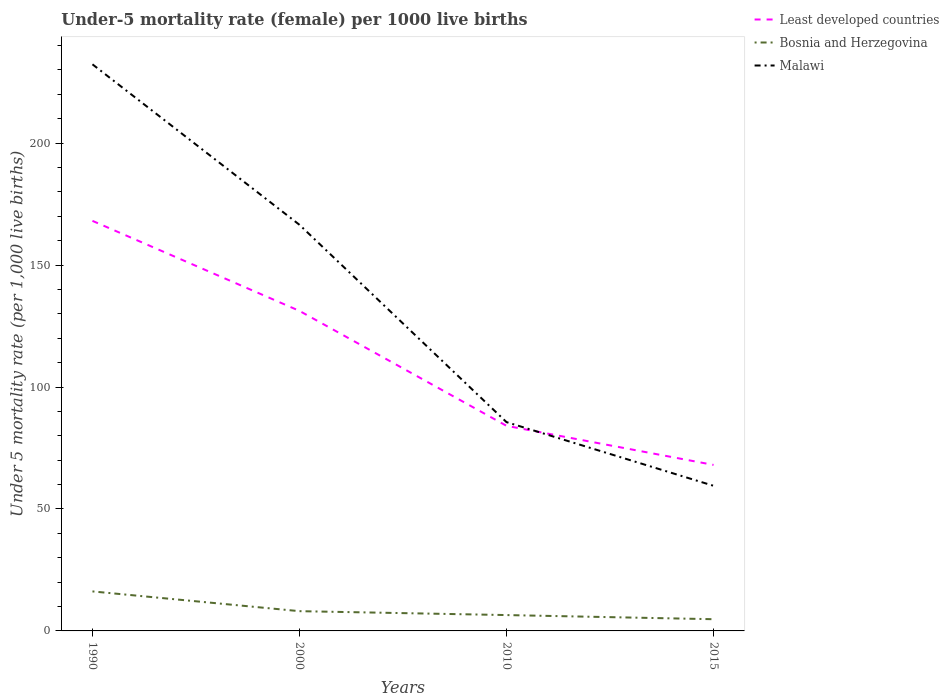Does the line corresponding to Least developed countries intersect with the line corresponding to Malawi?
Offer a very short reply. Yes. Is the number of lines equal to the number of legend labels?
Give a very brief answer. Yes. Across all years, what is the maximum under-five mortality rate in Malawi?
Provide a succinct answer. 59.5. In which year was the under-five mortality rate in Malawi maximum?
Ensure brevity in your answer.  2015. What is the total under-five mortality rate in Least developed countries in the graph?
Provide a succinct answer. 100.06. What is the difference between the highest and the second highest under-five mortality rate in Least developed countries?
Your answer should be very brief. 100.06. Is the under-five mortality rate in Malawi strictly greater than the under-five mortality rate in Least developed countries over the years?
Your response must be concise. No. How many lines are there?
Your response must be concise. 3. How many legend labels are there?
Ensure brevity in your answer.  3. How are the legend labels stacked?
Your answer should be very brief. Vertical. What is the title of the graph?
Make the answer very short. Under-5 mortality rate (female) per 1000 live births. What is the label or title of the Y-axis?
Your answer should be very brief. Under 5 mortality rate (per 1,0 live births). What is the Under 5 mortality rate (per 1,000 live births) in Least developed countries in 1990?
Provide a short and direct response. 168.12. What is the Under 5 mortality rate (per 1,000 live births) of Bosnia and Herzegovina in 1990?
Your answer should be compact. 16.2. What is the Under 5 mortality rate (per 1,000 live births) in Malawi in 1990?
Make the answer very short. 232.3. What is the Under 5 mortality rate (per 1,000 live births) in Least developed countries in 2000?
Your answer should be very brief. 131.2. What is the Under 5 mortality rate (per 1,000 live births) of Bosnia and Herzegovina in 2000?
Provide a short and direct response. 8.1. What is the Under 5 mortality rate (per 1,000 live births) in Malawi in 2000?
Provide a succinct answer. 166.5. What is the Under 5 mortality rate (per 1,000 live births) in Least developed countries in 2010?
Your answer should be very brief. 84.09. What is the Under 5 mortality rate (per 1,000 live births) in Bosnia and Herzegovina in 2010?
Your answer should be compact. 6.5. What is the Under 5 mortality rate (per 1,000 live births) of Malawi in 2010?
Provide a succinct answer. 85.6. What is the Under 5 mortality rate (per 1,000 live births) in Least developed countries in 2015?
Provide a short and direct response. 68.06. What is the Under 5 mortality rate (per 1,000 live births) in Malawi in 2015?
Your answer should be very brief. 59.5. Across all years, what is the maximum Under 5 mortality rate (per 1,000 live births) of Least developed countries?
Provide a succinct answer. 168.12. Across all years, what is the maximum Under 5 mortality rate (per 1,000 live births) in Malawi?
Your response must be concise. 232.3. Across all years, what is the minimum Under 5 mortality rate (per 1,000 live births) in Least developed countries?
Your answer should be compact. 68.06. Across all years, what is the minimum Under 5 mortality rate (per 1,000 live births) in Malawi?
Provide a succinct answer. 59.5. What is the total Under 5 mortality rate (per 1,000 live births) in Least developed countries in the graph?
Ensure brevity in your answer.  451.47. What is the total Under 5 mortality rate (per 1,000 live births) in Bosnia and Herzegovina in the graph?
Provide a short and direct response. 35.6. What is the total Under 5 mortality rate (per 1,000 live births) in Malawi in the graph?
Offer a very short reply. 543.9. What is the difference between the Under 5 mortality rate (per 1,000 live births) in Least developed countries in 1990 and that in 2000?
Give a very brief answer. 36.92. What is the difference between the Under 5 mortality rate (per 1,000 live births) of Malawi in 1990 and that in 2000?
Offer a terse response. 65.8. What is the difference between the Under 5 mortality rate (per 1,000 live births) in Least developed countries in 1990 and that in 2010?
Provide a succinct answer. 84.04. What is the difference between the Under 5 mortality rate (per 1,000 live births) of Bosnia and Herzegovina in 1990 and that in 2010?
Ensure brevity in your answer.  9.7. What is the difference between the Under 5 mortality rate (per 1,000 live births) of Malawi in 1990 and that in 2010?
Your answer should be compact. 146.7. What is the difference between the Under 5 mortality rate (per 1,000 live births) of Least developed countries in 1990 and that in 2015?
Your answer should be very brief. 100.06. What is the difference between the Under 5 mortality rate (per 1,000 live births) in Malawi in 1990 and that in 2015?
Offer a terse response. 172.8. What is the difference between the Under 5 mortality rate (per 1,000 live births) of Least developed countries in 2000 and that in 2010?
Give a very brief answer. 47.12. What is the difference between the Under 5 mortality rate (per 1,000 live births) of Bosnia and Herzegovina in 2000 and that in 2010?
Your answer should be very brief. 1.6. What is the difference between the Under 5 mortality rate (per 1,000 live births) of Malawi in 2000 and that in 2010?
Your answer should be very brief. 80.9. What is the difference between the Under 5 mortality rate (per 1,000 live births) in Least developed countries in 2000 and that in 2015?
Make the answer very short. 63.14. What is the difference between the Under 5 mortality rate (per 1,000 live births) in Bosnia and Herzegovina in 2000 and that in 2015?
Provide a succinct answer. 3.3. What is the difference between the Under 5 mortality rate (per 1,000 live births) of Malawi in 2000 and that in 2015?
Provide a short and direct response. 107. What is the difference between the Under 5 mortality rate (per 1,000 live births) of Least developed countries in 2010 and that in 2015?
Your answer should be very brief. 16.03. What is the difference between the Under 5 mortality rate (per 1,000 live births) of Bosnia and Herzegovina in 2010 and that in 2015?
Provide a succinct answer. 1.7. What is the difference between the Under 5 mortality rate (per 1,000 live births) in Malawi in 2010 and that in 2015?
Make the answer very short. 26.1. What is the difference between the Under 5 mortality rate (per 1,000 live births) in Least developed countries in 1990 and the Under 5 mortality rate (per 1,000 live births) in Bosnia and Herzegovina in 2000?
Provide a short and direct response. 160.02. What is the difference between the Under 5 mortality rate (per 1,000 live births) of Least developed countries in 1990 and the Under 5 mortality rate (per 1,000 live births) of Malawi in 2000?
Your response must be concise. 1.62. What is the difference between the Under 5 mortality rate (per 1,000 live births) in Bosnia and Herzegovina in 1990 and the Under 5 mortality rate (per 1,000 live births) in Malawi in 2000?
Keep it short and to the point. -150.3. What is the difference between the Under 5 mortality rate (per 1,000 live births) of Least developed countries in 1990 and the Under 5 mortality rate (per 1,000 live births) of Bosnia and Herzegovina in 2010?
Make the answer very short. 161.62. What is the difference between the Under 5 mortality rate (per 1,000 live births) in Least developed countries in 1990 and the Under 5 mortality rate (per 1,000 live births) in Malawi in 2010?
Provide a succinct answer. 82.52. What is the difference between the Under 5 mortality rate (per 1,000 live births) in Bosnia and Herzegovina in 1990 and the Under 5 mortality rate (per 1,000 live births) in Malawi in 2010?
Your response must be concise. -69.4. What is the difference between the Under 5 mortality rate (per 1,000 live births) in Least developed countries in 1990 and the Under 5 mortality rate (per 1,000 live births) in Bosnia and Herzegovina in 2015?
Offer a very short reply. 163.32. What is the difference between the Under 5 mortality rate (per 1,000 live births) of Least developed countries in 1990 and the Under 5 mortality rate (per 1,000 live births) of Malawi in 2015?
Your response must be concise. 108.62. What is the difference between the Under 5 mortality rate (per 1,000 live births) of Bosnia and Herzegovina in 1990 and the Under 5 mortality rate (per 1,000 live births) of Malawi in 2015?
Provide a short and direct response. -43.3. What is the difference between the Under 5 mortality rate (per 1,000 live births) of Least developed countries in 2000 and the Under 5 mortality rate (per 1,000 live births) of Bosnia and Herzegovina in 2010?
Your response must be concise. 124.7. What is the difference between the Under 5 mortality rate (per 1,000 live births) in Least developed countries in 2000 and the Under 5 mortality rate (per 1,000 live births) in Malawi in 2010?
Your response must be concise. 45.6. What is the difference between the Under 5 mortality rate (per 1,000 live births) of Bosnia and Herzegovina in 2000 and the Under 5 mortality rate (per 1,000 live births) of Malawi in 2010?
Give a very brief answer. -77.5. What is the difference between the Under 5 mortality rate (per 1,000 live births) of Least developed countries in 2000 and the Under 5 mortality rate (per 1,000 live births) of Bosnia and Herzegovina in 2015?
Provide a succinct answer. 126.4. What is the difference between the Under 5 mortality rate (per 1,000 live births) of Least developed countries in 2000 and the Under 5 mortality rate (per 1,000 live births) of Malawi in 2015?
Make the answer very short. 71.7. What is the difference between the Under 5 mortality rate (per 1,000 live births) in Bosnia and Herzegovina in 2000 and the Under 5 mortality rate (per 1,000 live births) in Malawi in 2015?
Provide a succinct answer. -51.4. What is the difference between the Under 5 mortality rate (per 1,000 live births) of Least developed countries in 2010 and the Under 5 mortality rate (per 1,000 live births) of Bosnia and Herzegovina in 2015?
Provide a succinct answer. 79.29. What is the difference between the Under 5 mortality rate (per 1,000 live births) of Least developed countries in 2010 and the Under 5 mortality rate (per 1,000 live births) of Malawi in 2015?
Offer a very short reply. 24.59. What is the difference between the Under 5 mortality rate (per 1,000 live births) of Bosnia and Herzegovina in 2010 and the Under 5 mortality rate (per 1,000 live births) of Malawi in 2015?
Give a very brief answer. -53. What is the average Under 5 mortality rate (per 1,000 live births) in Least developed countries per year?
Give a very brief answer. 112.87. What is the average Under 5 mortality rate (per 1,000 live births) in Malawi per year?
Make the answer very short. 135.97. In the year 1990, what is the difference between the Under 5 mortality rate (per 1,000 live births) in Least developed countries and Under 5 mortality rate (per 1,000 live births) in Bosnia and Herzegovina?
Your answer should be compact. 151.92. In the year 1990, what is the difference between the Under 5 mortality rate (per 1,000 live births) in Least developed countries and Under 5 mortality rate (per 1,000 live births) in Malawi?
Provide a succinct answer. -64.18. In the year 1990, what is the difference between the Under 5 mortality rate (per 1,000 live births) of Bosnia and Herzegovina and Under 5 mortality rate (per 1,000 live births) of Malawi?
Make the answer very short. -216.1. In the year 2000, what is the difference between the Under 5 mortality rate (per 1,000 live births) of Least developed countries and Under 5 mortality rate (per 1,000 live births) of Bosnia and Herzegovina?
Your response must be concise. 123.1. In the year 2000, what is the difference between the Under 5 mortality rate (per 1,000 live births) of Least developed countries and Under 5 mortality rate (per 1,000 live births) of Malawi?
Your response must be concise. -35.3. In the year 2000, what is the difference between the Under 5 mortality rate (per 1,000 live births) in Bosnia and Herzegovina and Under 5 mortality rate (per 1,000 live births) in Malawi?
Ensure brevity in your answer.  -158.4. In the year 2010, what is the difference between the Under 5 mortality rate (per 1,000 live births) in Least developed countries and Under 5 mortality rate (per 1,000 live births) in Bosnia and Herzegovina?
Provide a short and direct response. 77.59. In the year 2010, what is the difference between the Under 5 mortality rate (per 1,000 live births) in Least developed countries and Under 5 mortality rate (per 1,000 live births) in Malawi?
Your response must be concise. -1.51. In the year 2010, what is the difference between the Under 5 mortality rate (per 1,000 live births) in Bosnia and Herzegovina and Under 5 mortality rate (per 1,000 live births) in Malawi?
Your response must be concise. -79.1. In the year 2015, what is the difference between the Under 5 mortality rate (per 1,000 live births) of Least developed countries and Under 5 mortality rate (per 1,000 live births) of Bosnia and Herzegovina?
Your answer should be very brief. 63.26. In the year 2015, what is the difference between the Under 5 mortality rate (per 1,000 live births) in Least developed countries and Under 5 mortality rate (per 1,000 live births) in Malawi?
Ensure brevity in your answer.  8.56. In the year 2015, what is the difference between the Under 5 mortality rate (per 1,000 live births) in Bosnia and Herzegovina and Under 5 mortality rate (per 1,000 live births) in Malawi?
Offer a very short reply. -54.7. What is the ratio of the Under 5 mortality rate (per 1,000 live births) in Least developed countries in 1990 to that in 2000?
Provide a short and direct response. 1.28. What is the ratio of the Under 5 mortality rate (per 1,000 live births) in Malawi in 1990 to that in 2000?
Offer a terse response. 1.4. What is the ratio of the Under 5 mortality rate (per 1,000 live births) of Least developed countries in 1990 to that in 2010?
Offer a very short reply. 2. What is the ratio of the Under 5 mortality rate (per 1,000 live births) in Bosnia and Herzegovina in 1990 to that in 2010?
Keep it short and to the point. 2.49. What is the ratio of the Under 5 mortality rate (per 1,000 live births) of Malawi in 1990 to that in 2010?
Ensure brevity in your answer.  2.71. What is the ratio of the Under 5 mortality rate (per 1,000 live births) in Least developed countries in 1990 to that in 2015?
Your answer should be compact. 2.47. What is the ratio of the Under 5 mortality rate (per 1,000 live births) of Bosnia and Herzegovina in 1990 to that in 2015?
Ensure brevity in your answer.  3.38. What is the ratio of the Under 5 mortality rate (per 1,000 live births) of Malawi in 1990 to that in 2015?
Your answer should be very brief. 3.9. What is the ratio of the Under 5 mortality rate (per 1,000 live births) of Least developed countries in 2000 to that in 2010?
Offer a very short reply. 1.56. What is the ratio of the Under 5 mortality rate (per 1,000 live births) in Bosnia and Herzegovina in 2000 to that in 2010?
Offer a very short reply. 1.25. What is the ratio of the Under 5 mortality rate (per 1,000 live births) in Malawi in 2000 to that in 2010?
Provide a succinct answer. 1.95. What is the ratio of the Under 5 mortality rate (per 1,000 live births) of Least developed countries in 2000 to that in 2015?
Make the answer very short. 1.93. What is the ratio of the Under 5 mortality rate (per 1,000 live births) in Bosnia and Herzegovina in 2000 to that in 2015?
Your answer should be compact. 1.69. What is the ratio of the Under 5 mortality rate (per 1,000 live births) of Malawi in 2000 to that in 2015?
Give a very brief answer. 2.8. What is the ratio of the Under 5 mortality rate (per 1,000 live births) in Least developed countries in 2010 to that in 2015?
Keep it short and to the point. 1.24. What is the ratio of the Under 5 mortality rate (per 1,000 live births) of Bosnia and Herzegovina in 2010 to that in 2015?
Your response must be concise. 1.35. What is the ratio of the Under 5 mortality rate (per 1,000 live births) in Malawi in 2010 to that in 2015?
Keep it short and to the point. 1.44. What is the difference between the highest and the second highest Under 5 mortality rate (per 1,000 live births) of Least developed countries?
Keep it short and to the point. 36.92. What is the difference between the highest and the second highest Under 5 mortality rate (per 1,000 live births) of Malawi?
Give a very brief answer. 65.8. What is the difference between the highest and the lowest Under 5 mortality rate (per 1,000 live births) of Least developed countries?
Make the answer very short. 100.06. What is the difference between the highest and the lowest Under 5 mortality rate (per 1,000 live births) of Malawi?
Your response must be concise. 172.8. 